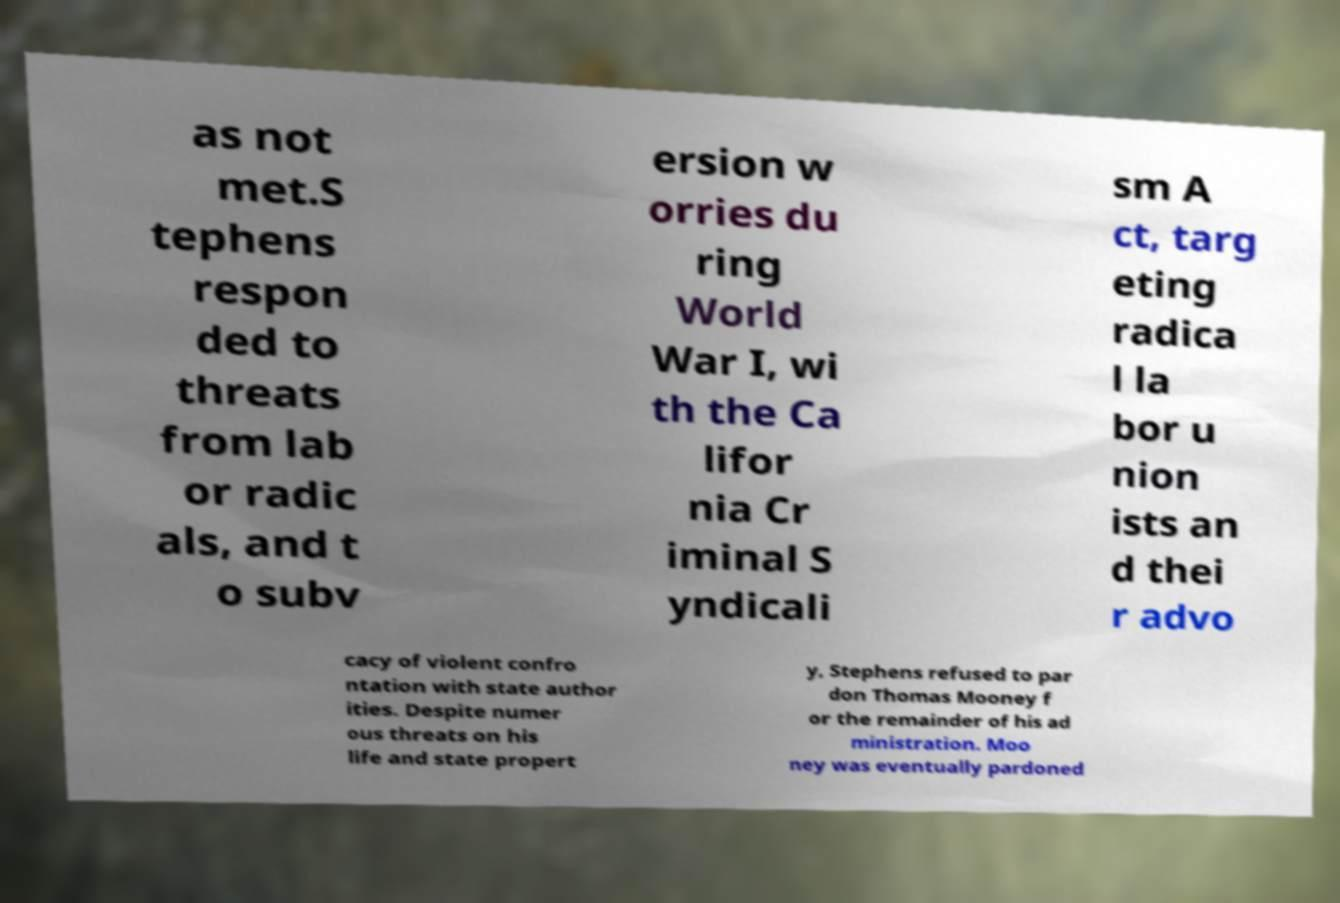There's text embedded in this image that I need extracted. Can you transcribe it verbatim? as not met.S tephens respon ded to threats from lab or radic als, and t o subv ersion w orries du ring World War I, wi th the Ca lifor nia Cr iminal S yndicali sm A ct, targ eting radica l la bor u nion ists an d thei r advo cacy of violent confro ntation with state author ities. Despite numer ous threats on his life and state propert y, Stephens refused to par don Thomas Mooney f or the remainder of his ad ministration. Moo ney was eventually pardoned 